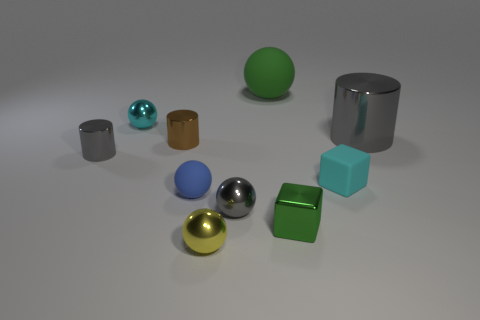Subtract all small yellow spheres. How many spheres are left? 4 Subtract all blue cubes. How many gray cylinders are left? 2 Subtract all green cubes. How many cubes are left? 1 Subtract 2 spheres. How many spheres are left? 3 Subtract all cylinders. How many objects are left? 7 Add 3 tiny cylinders. How many tiny cylinders are left? 5 Add 9 small matte cubes. How many small matte cubes exist? 10 Subtract 0 yellow cylinders. How many objects are left? 10 Subtract all cyan balls. Subtract all gray cylinders. How many balls are left? 4 Subtract all tiny red rubber balls. Subtract all tiny gray balls. How many objects are left? 9 